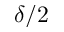<formula> <loc_0><loc_0><loc_500><loc_500>\delta / 2</formula> 